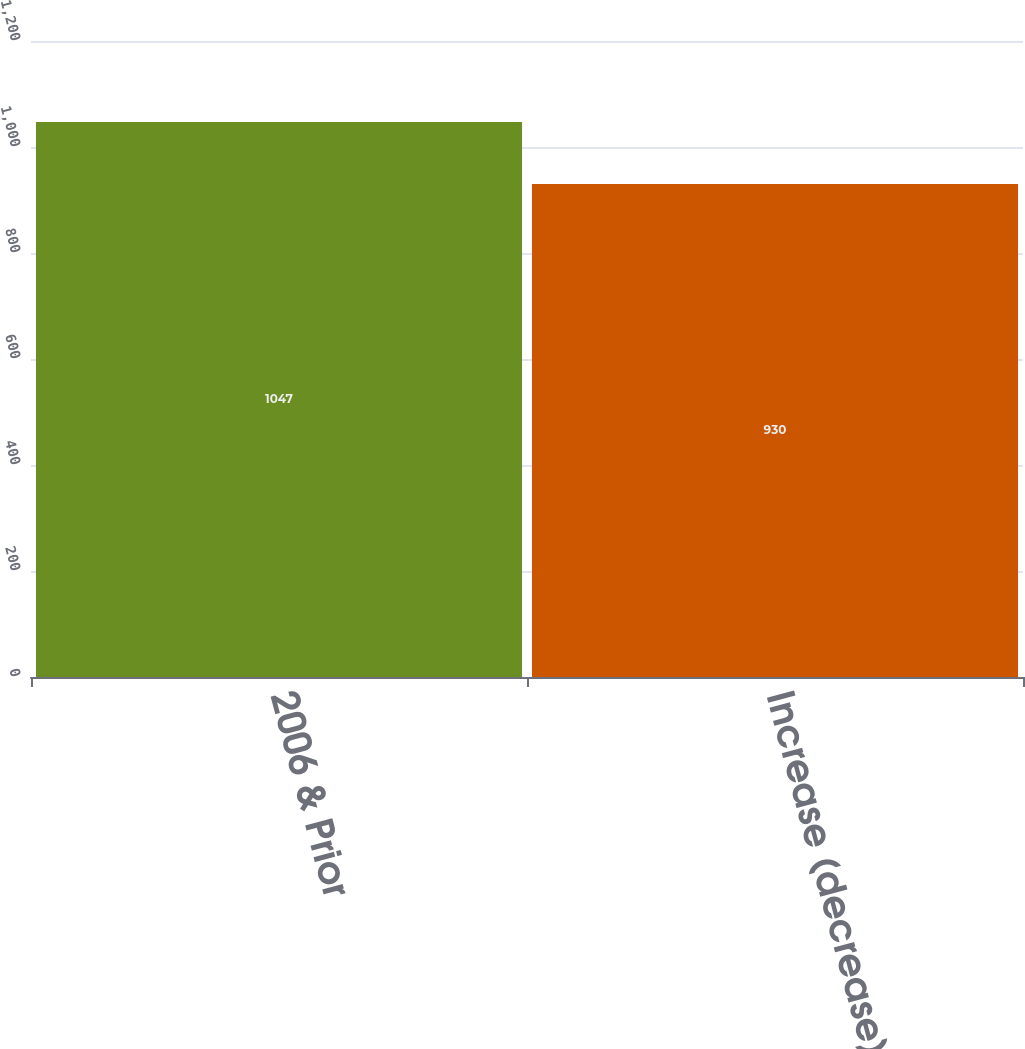Convert chart. <chart><loc_0><loc_0><loc_500><loc_500><bar_chart><fcel>2006 & Prior<fcel>Increase (decrease) in net<nl><fcel>1047<fcel>930<nl></chart> 